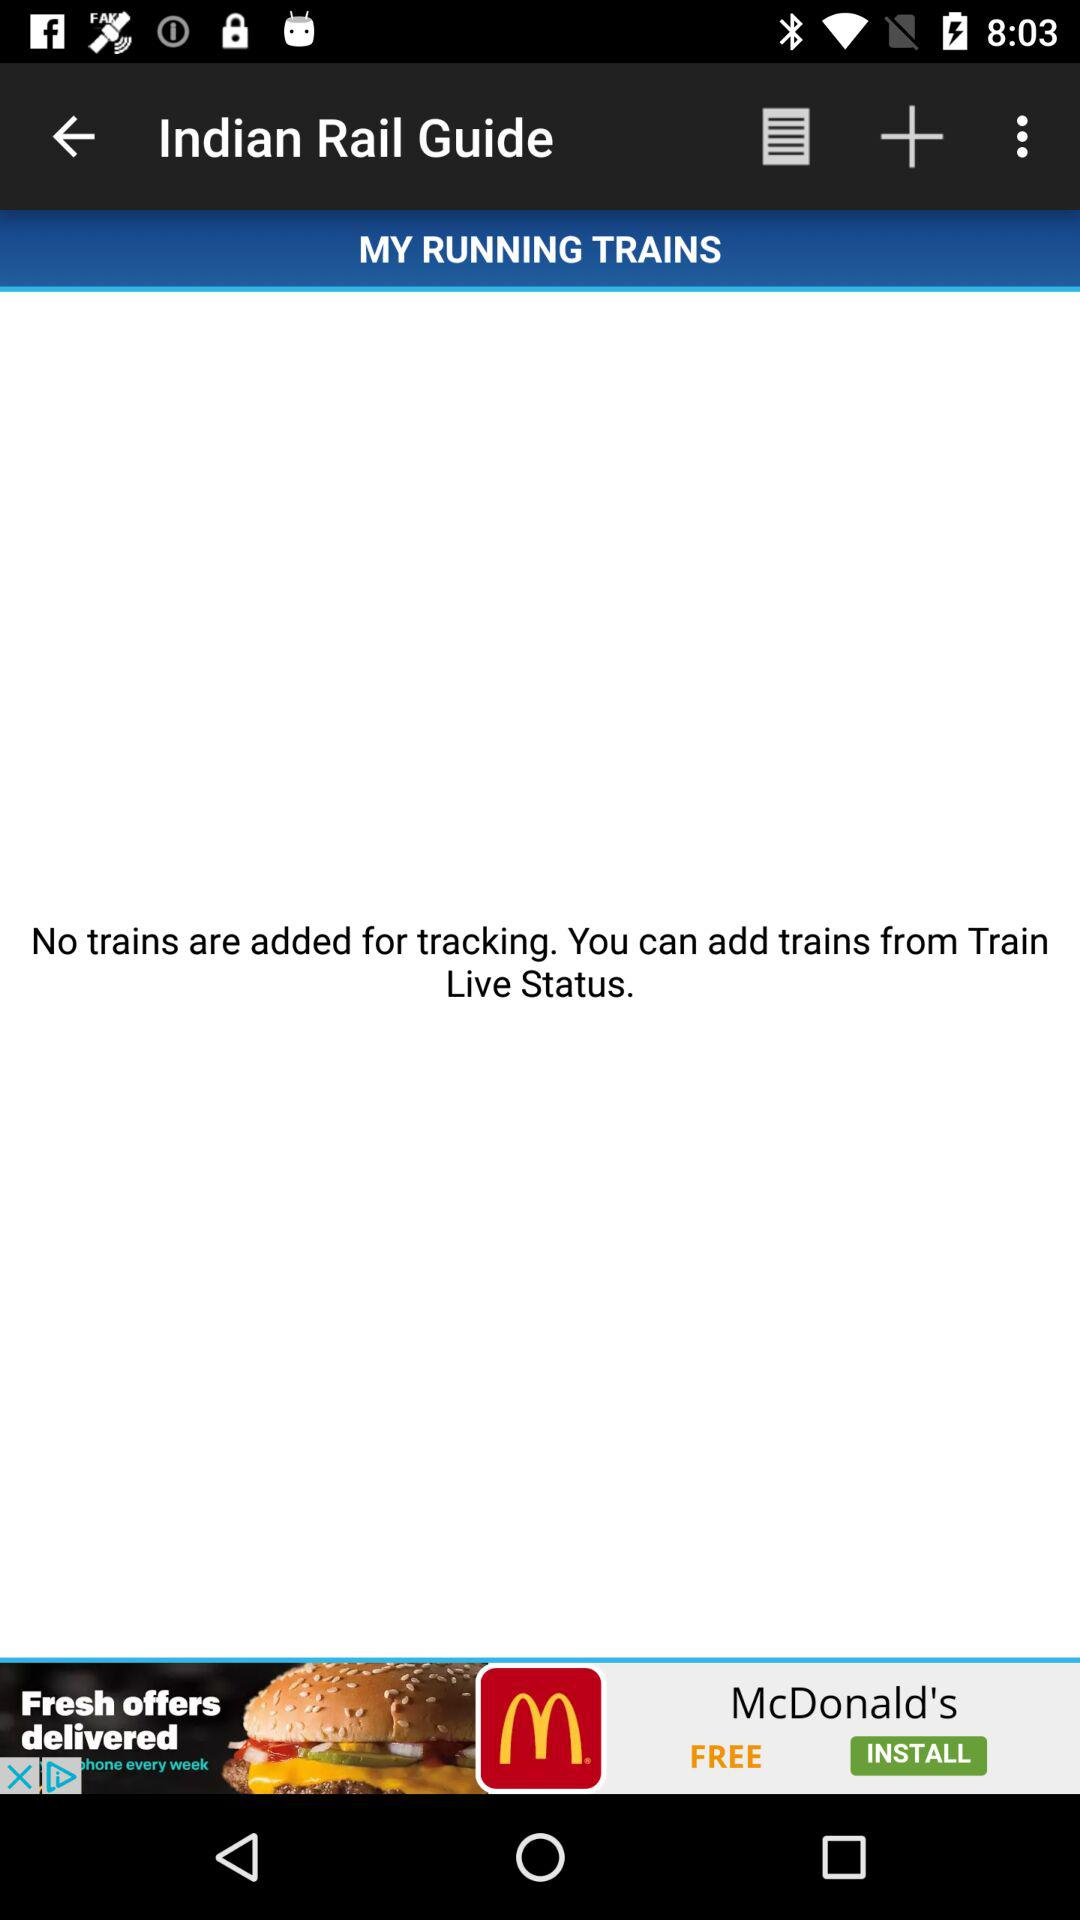Are there any trains added for tracking? There are no trains added for tracking. 